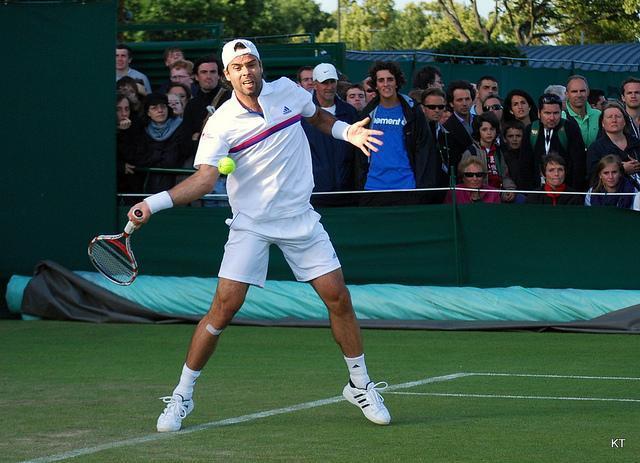How many tennis balls do you see?
Give a very brief answer. 1. How many people are there?
Give a very brief answer. 7. 